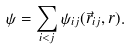Convert formula to latex. <formula><loc_0><loc_0><loc_500><loc_500>\psi = \sum _ { i < j } \psi _ { i j } ( \vec { r } _ { i j } , r ) .</formula> 